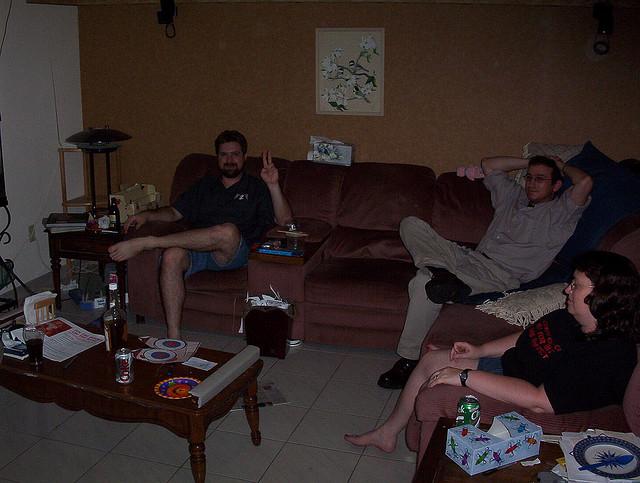Is this a real or fake scene?
Answer briefly. Real. How many total bottles are pictured?
Write a very short answer. 1. Is the man on the couch laying down?
Quick response, please. No. How many men are wearing hats?
Concise answer only. 0. Is this the same person?
Be succinct. No. Is the floor carpeted?
Answer briefly. No. Where are the toes?
Be succinct. Floor. Is this in color?
Give a very brief answer. Yes. Was the person taking the picture sitting down?
Quick response, please. No. What are they sitting on?
Give a very brief answer. Couch. Are the person's shoes tied?
Keep it brief. Yes. Are all the people watching TV?
Be succinct. Yes. Is this photo colored?
Concise answer only. Yes. What is stacked next to the woman?
Short answer required. Tissues. How many table can you see?
Give a very brief answer. 1. Is the object in the chair alive?
Be succinct. Yes. What is inside the blue box on the table?
Short answer required. Tissues. Does the chair have a cup holder?
Keep it brief. Yes. How many feet are in the picture?
Short answer required. 6. How many boys in the picture?
Keep it brief. 2. What is written on the paper sitting on the table?
Answer briefly. Article. Are these real or toy people?
Give a very brief answer. Real. What are these people in?
Write a very short answer. Living room. How many pictures on wall?
Quick response, please. 1. What is the blue paint pattern on the wall?
Write a very short answer. Painting. What room of the house is this?
Give a very brief answer. Living room. What is on the table?
Be succinct. Drinks. How many people are sitting?
Quick response, please. 3. How much time do the average American spend watching t.v.?
Be succinct. 3 hours day. What color is the wall?
Be succinct. Brown. Are the boys skateboarding?
Keep it brief. No. What type of chair is this woman sitting in?
Be succinct. Recliner. How many people are in the photo?
Short answer required. 3. How many people are wearing hats?
Concise answer only. 0. How many people are wearing glasses?
Short answer required. 2. What does the young girl have in her hand?
Give a very brief answer. Nothing. Is it sunny?
Be succinct. No. What color is the floor?
Give a very brief answer. White. Are these people happy?
Write a very short answer. Yes. Is the lamp on?
Answer briefly. No. Are they sitting outside?
Short answer required. No. How many people are posing?
Be succinct. 1. What are these people doing?
Answer briefly. Sitting. Which leg is on top?
Give a very brief answer. Right. How many chairs are visible?
Write a very short answer. 1. What is on the woman's wrist?
Concise answer only. Watch. Is this a sectional couch?
Write a very short answer. Yes. What is sitting on the far right woman's lap?
Write a very short answer. Hand. Is the figure on the right a doll?
Keep it brief. No. How many chairs are there?
Short answer required. 1. Is this woman fashionable?
Write a very short answer. No. Are both couches a single solid color?
Concise answer only. Yes. What color shorts is the man wearing?
Be succinct. Blue. Does this chair recline?
Be succinct. No. Is one woman sitting on the ground?
Concise answer only. No. What color is the napkin?
Answer briefly. White. What leg is in the air?
Short answer required. Left. What color is the bottle?
Quick response, please. Clear. Do these people seem to be entertained?
Short answer required. Yes. Are the boys cleaning a bathroom?
Answer briefly. No. How many shoes are shown?
Be succinct. 2. Is the laptop turned on?
Keep it brief. No. What are the women drinking?
Concise answer only. Soda. How many people are wearing gray shirts?
Keep it brief. 1. Is the picture black and white?
Write a very short answer. No. Which side shoe does the man have off?
Concise answer only. Left. Should he wear a helmet to be safe?
Write a very short answer. No. 